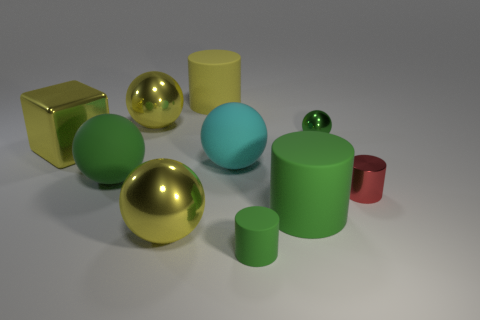Is the number of cylinders less than the number of small green metal objects?
Your response must be concise. No. There is a matte cylinder behind the green shiny ball; what is its size?
Provide a short and direct response. Large. The shiny object that is on the right side of the big yellow cylinder and to the left of the small red metallic cylinder has what shape?
Offer a very short reply. Sphere. The yellow thing that is the same shape as the red thing is what size?
Offer a terse response. Large. How many big yellow objects are made of the same material as the block?
Give a very brief answer. 2. There is a tiny matte cylinder; is its color the same as the ball that is right of the small green matte thing?
Your answer should be very brief. Yes. Is the number of big yellow matte objects greater than the number of big blue rubber spheres?
Your answer should be compact. Yes. What color is the big block?
Provide a succinct answer. Yellow. Is the color of the tiny object that is right of the tiny green metal object the same as the big cube?
Make the answer very short. No. There is a big cylinder that is the same color as the small shiny ball; what is it made of?
Provide a short and direct response. Rubber. 